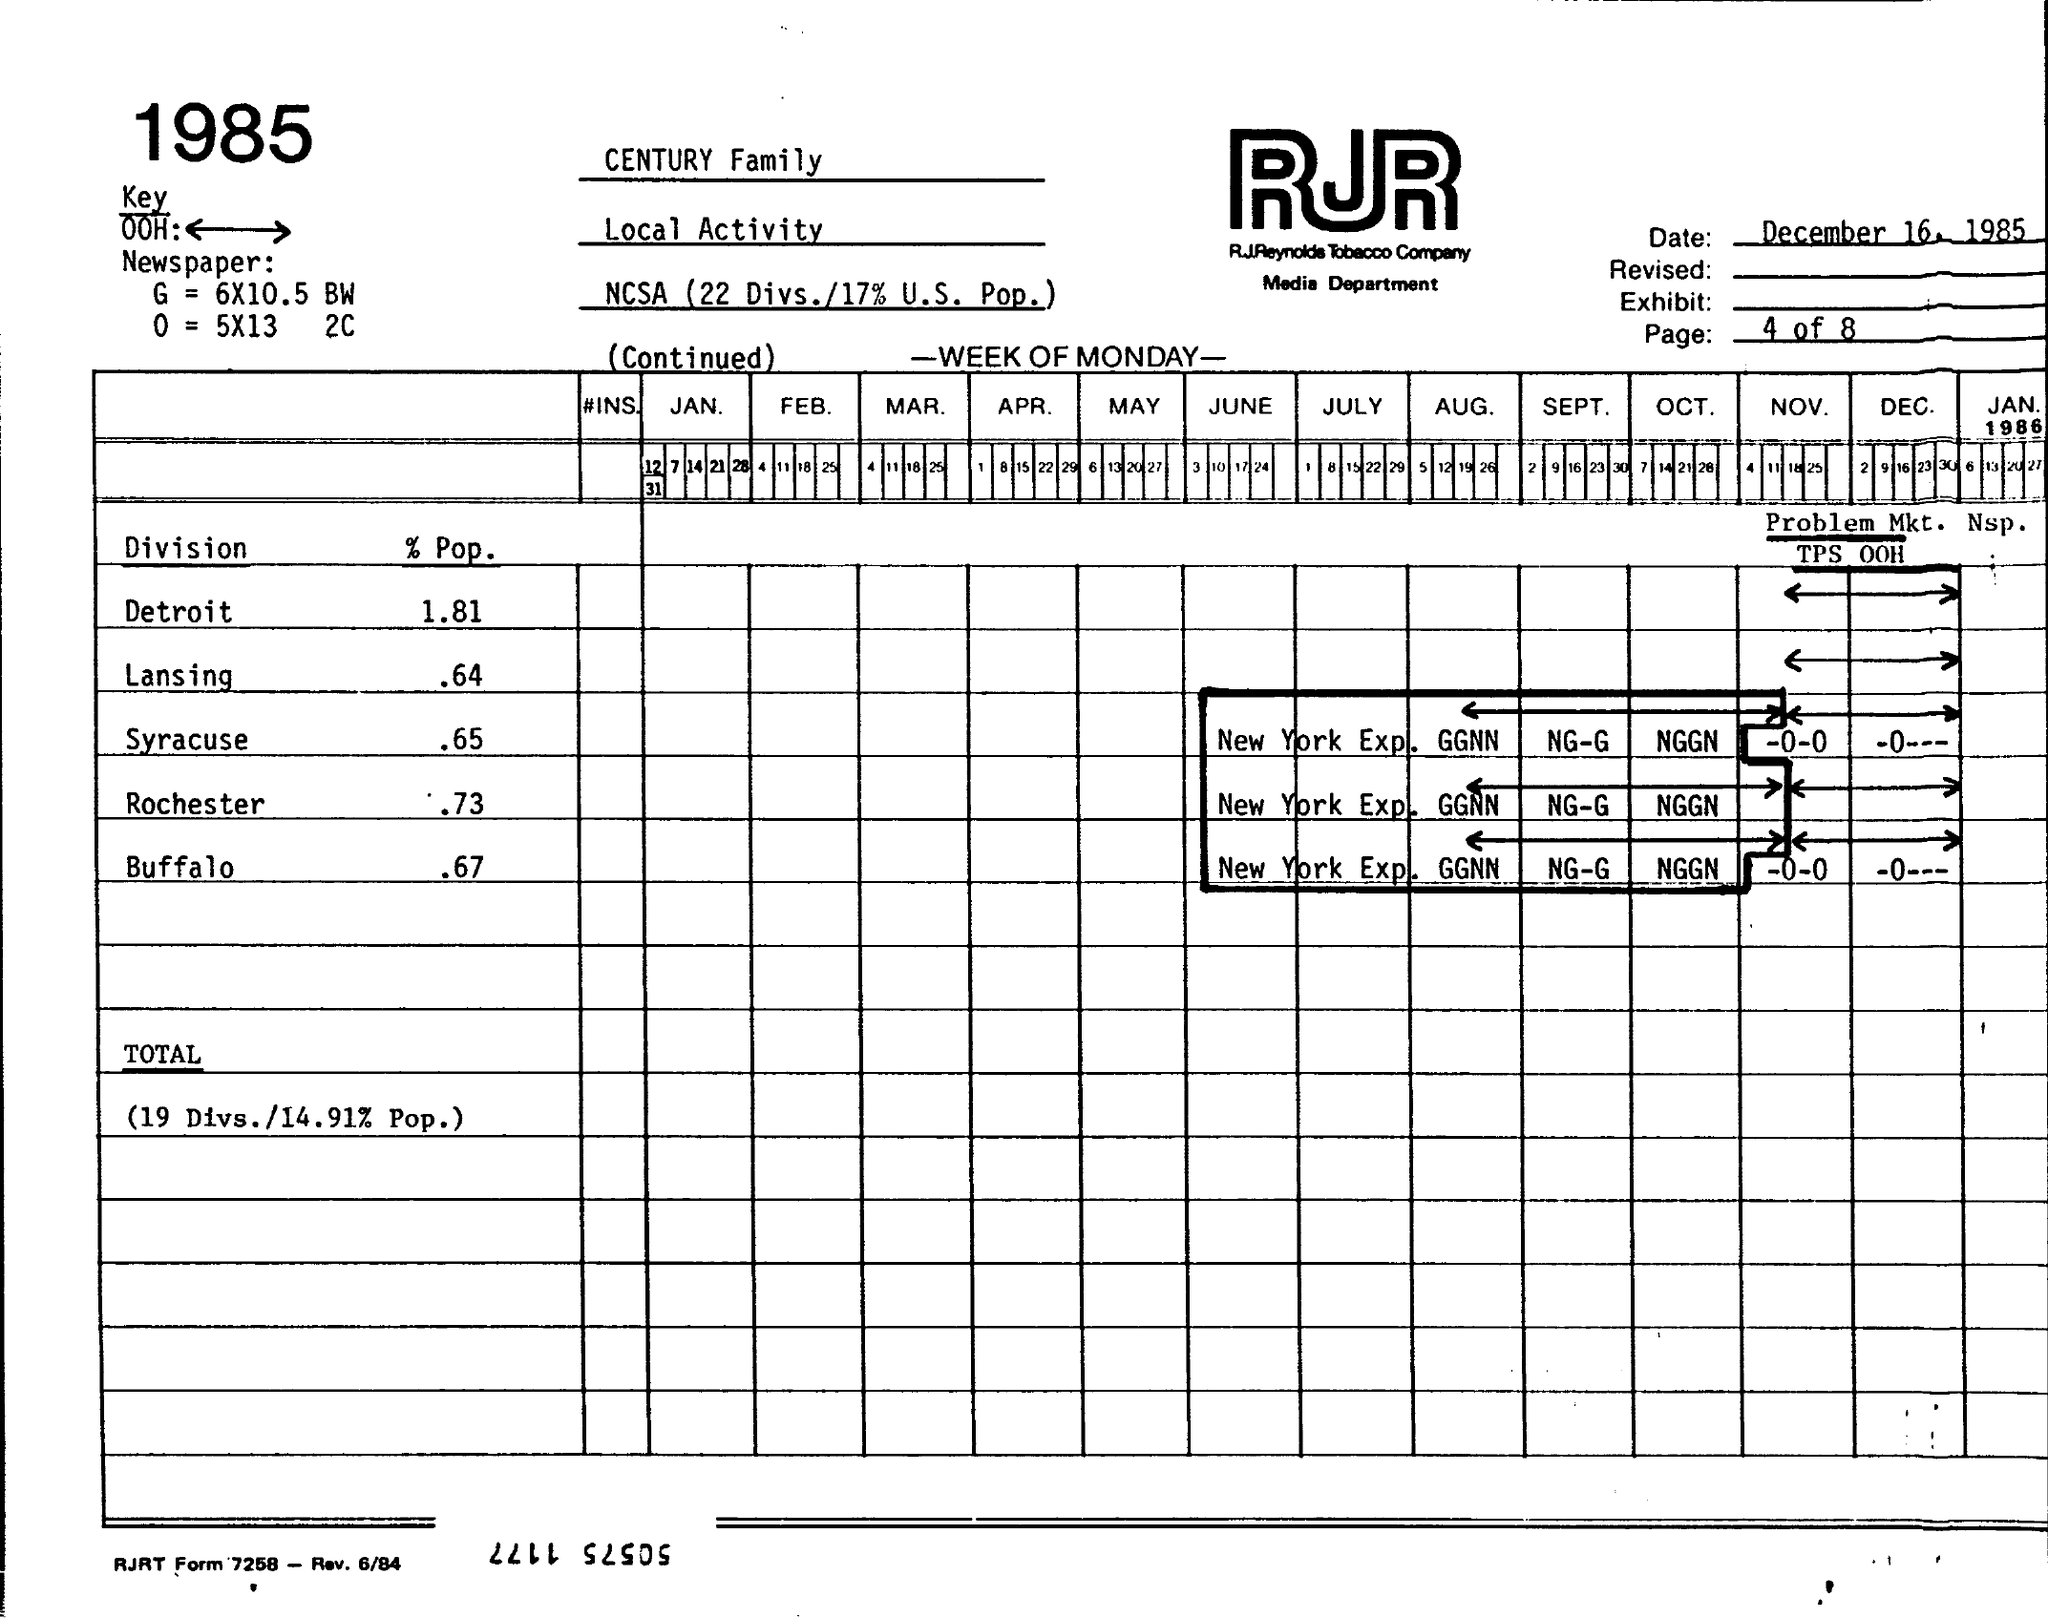What is the % Pop for Detroit?
 1.81 